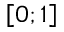Convert formula to latex. <formula><loc_0><loc_0><loc_500><loc_500>\left [ 0 ; 1 \right ]</formula> 